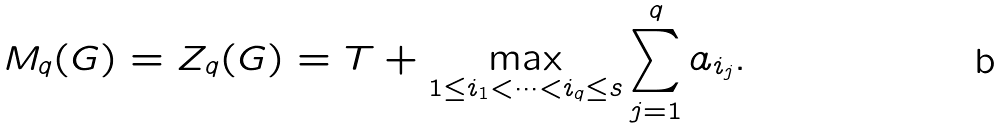Convert formula to latex. <formula><loc_0><loc_0><loc_500><loc_500>M _ { q } ( G ) = Z _ { q } ( G ) = T + \max _ { 1 \leq i _ { 1 } < \dots < i _ { q } \leq s } \sum _ { j = 1 } ^ { q } a _ { i _ { j } } .</formula> 